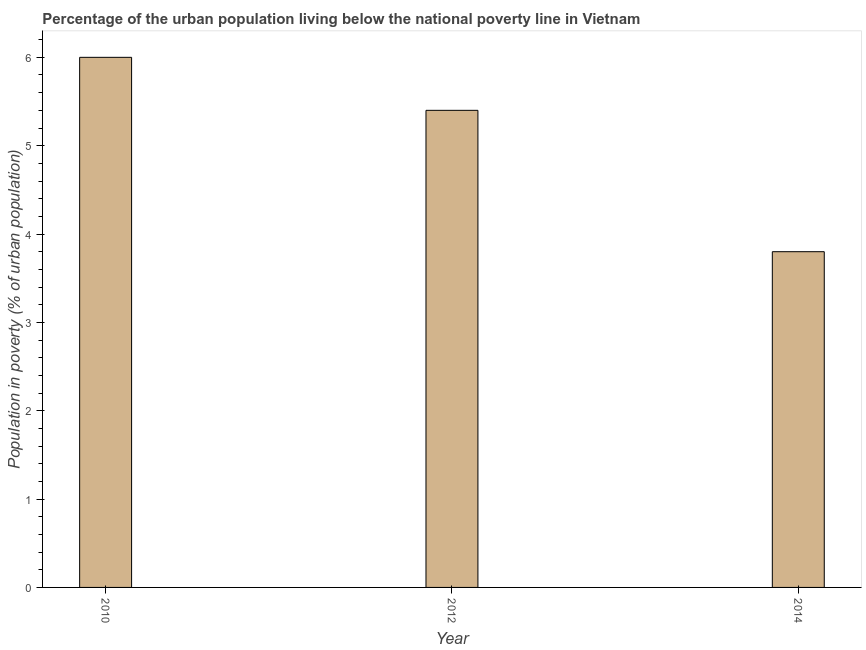What is the title of the graph?
Your answer should be compact. Percentage of the urban population living below the national poverty line in Vietnam. What is the label or title of the Y-axis?
Provide a succinct answer. Population in poverty (% of urban population). What is the percentage of urban population living below poverty line in 2014?
Offer a very short reply. 3.8. Across all years, what is the maximum percentage of urban population living below poverty line?
Make the answer very short. 6. Across all years, what is the minimum percentage of urban population living below poverty line?
Offer a terse response. 3.8. In which year was the percentage of urban population living below poverty line maximum?
Your response must be concise. 2010. In which year was the percentage of urban population living below poverty line minimum?
Your answer should be very brief. 2014. What is the sum of the percentage of urban population living below poverty line?
Your response must be concise. 15.2. What is the difference between the percentage of urban population living below poverty line in 2012 and 2014?
Provide a short and direct response. 1.6. What is the average percentage of urban population living below poverty line per year?
Offer a terse response. 5.07. What is the ratio of the percentage of urban population living below poverty line in 2010 to that in 2014?
Provide a short and direct response. 1.58. Is the difference between the percentage of urban population living below poverty line in 2010 and 2012 greater than the difference between any two years?
Offer a terse response. No. What is the difference between the highest and the second highest percentage of urban population living below poverty line?
Your response must be concise. 0.6. Is the sum of the percentage of urban population living below poverty line in 2012 and 2014 greater than the maximum percentage of urban population living below poverty line across all years?
Offer a terse response. Yes. What is the difference between the highest and the lowest percentage of urban population living below poverty line?
Give a very brief answer. 2.2. In how many years, is the percentage of urban population living below poverty line greater than the average percentage of urban population living below poverty line taken over all years?
Your response must be concise. 2. How many bars are there?
Give a very brief answer. 3. Are all the bars in the graph horizontal?
Your answer should be very brief. No. How many years are there in the graph?
Keep it short and to the point. 3. Are the values on the major ticks of Y-axis written in scientific E-notation?
Make the answer very short. No. What is the Population in poverty (% of urban population) of 2010?
Your answer should be very brief. 6. What is the Population in poverty (% of urban population) of 2012?
Offer a very short reply. 5.4. What is the difference between the Population in poverty (% of urban population) in 2010 and 2014?
Provide a succinct answer. 2.2. What is the difference between the Population in poverty (% of urban population) in 2012 and 2014?
Provide a succinct answer. 1.6. What is the ratio of the Population in poverty (% of urban population) in 2010 to that in 2012?
Provide a succinct answer. 1.11. What is the ratio of the Population in poverty (% of urban population) in 2010 to that in 2014?
Make the answer very short. 1.58. What is the ratio of the Population in poverty (% of urban population) in 2012 to that in 2014?
Your answer should be compact. 1.42. 